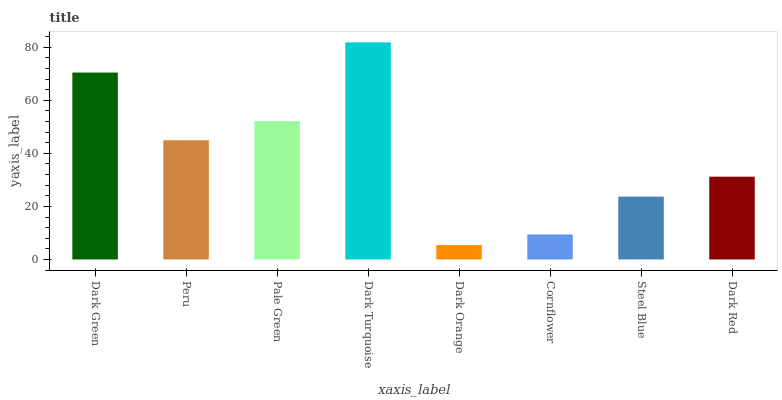Is Dark Orange the minimum?
Answer yes or no. Yes. Is Dark Turquoise the maximum?
Answer yes or no. Yes. Is Peru the minimum?
Answer yes or no. No. Is Peru the maximum?
Answer yes or no. No. Is Dark Green greater than Peru?
Answer yes or no. Yes. Is Peru less than Dark Green?
Answer yes or no. Yes. Is Peru greater than Dark Green?
Answer yes or no. No. Is Dark Green less than Peru?
Answer yes or no. No. Is Peru the high median?
Answer yes or no. Yes. Is Dark Red the low median?
Answer yes or no. Yes. Is Dark Turquoise the high median?
Answer yes or no. No. Is Pale Green the low median?
Answer yes or no. No. 